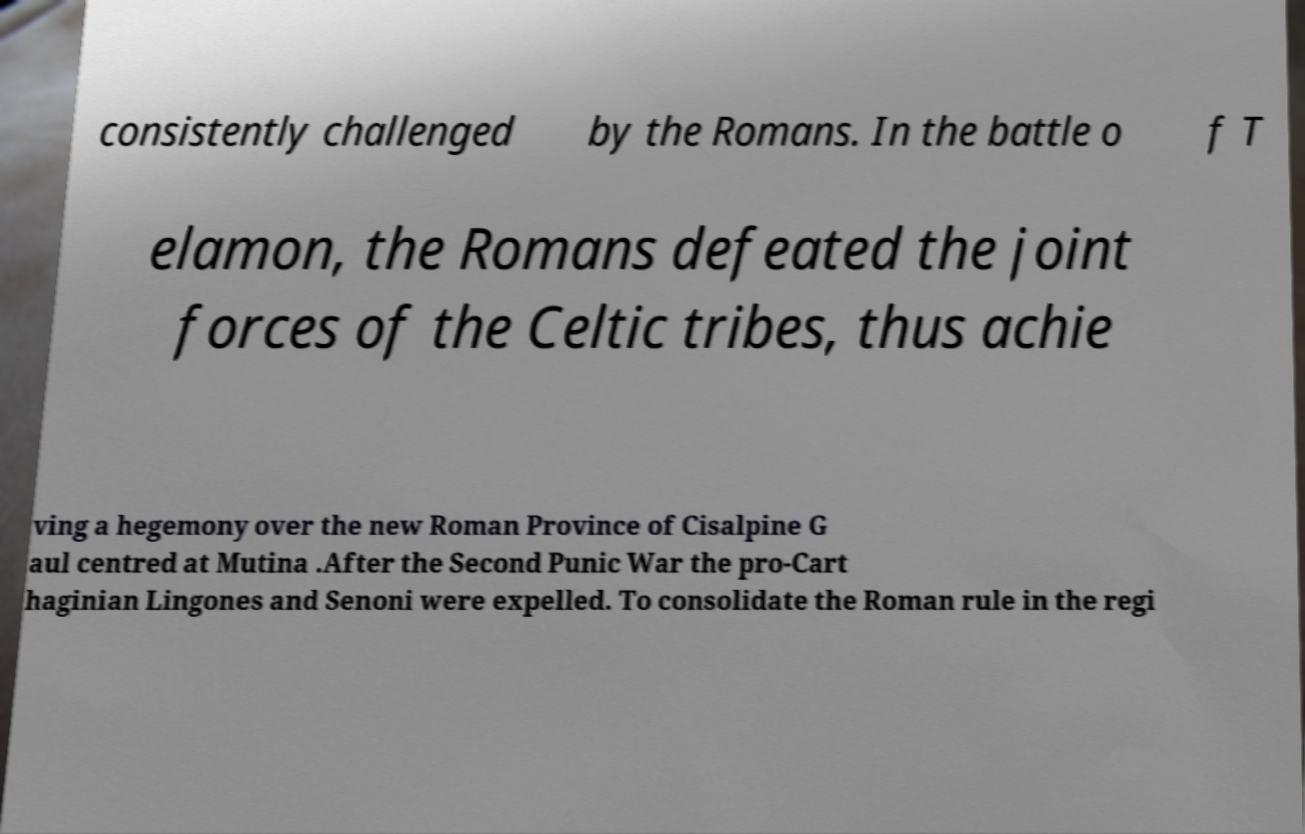For documentation purposes, I need the text within this image transcribed. Could you provide that? consistently challenged by the Romans. In the battle o f T elamon, the Romans defeated the joint forces of the Celtic tribes, thus achie ving a hegemony over the new Roman Province of Cisalpine G aul centred at Mutina .After the Second Punic War the pro-Cart haginian Lingones and Senoni were expelled. To consolidate the Roman rule in the regi 